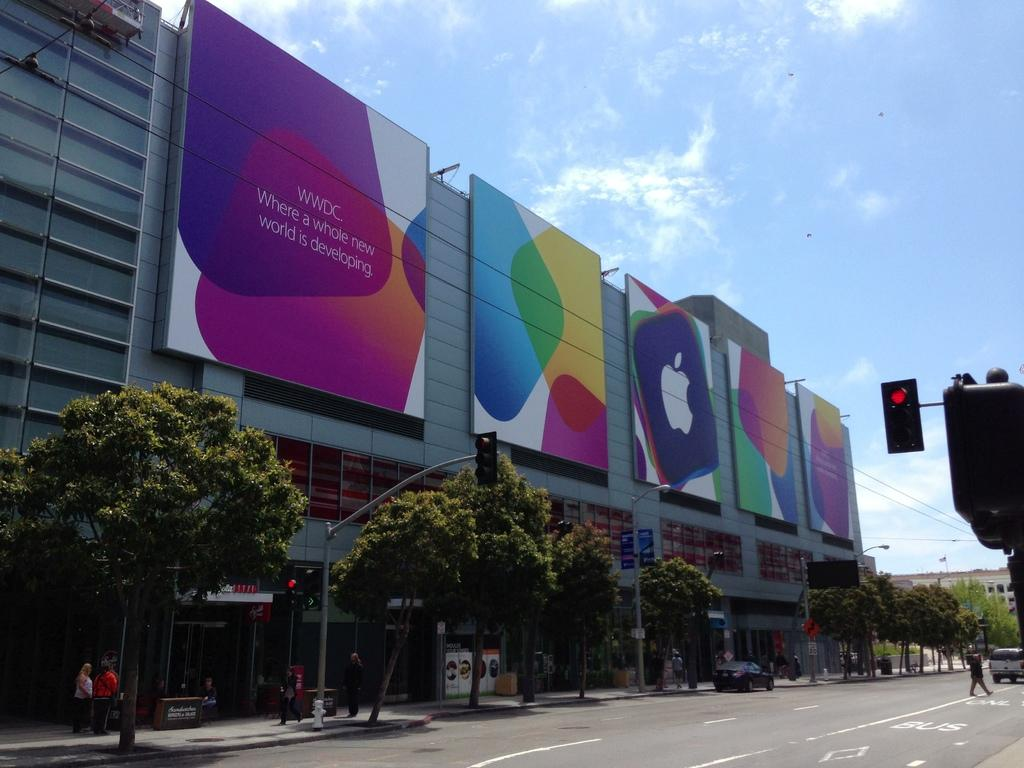<image>
Present a compact description of the photo's key features. A series of bilboards has the apple logo and the abbreviation "WWDC." 